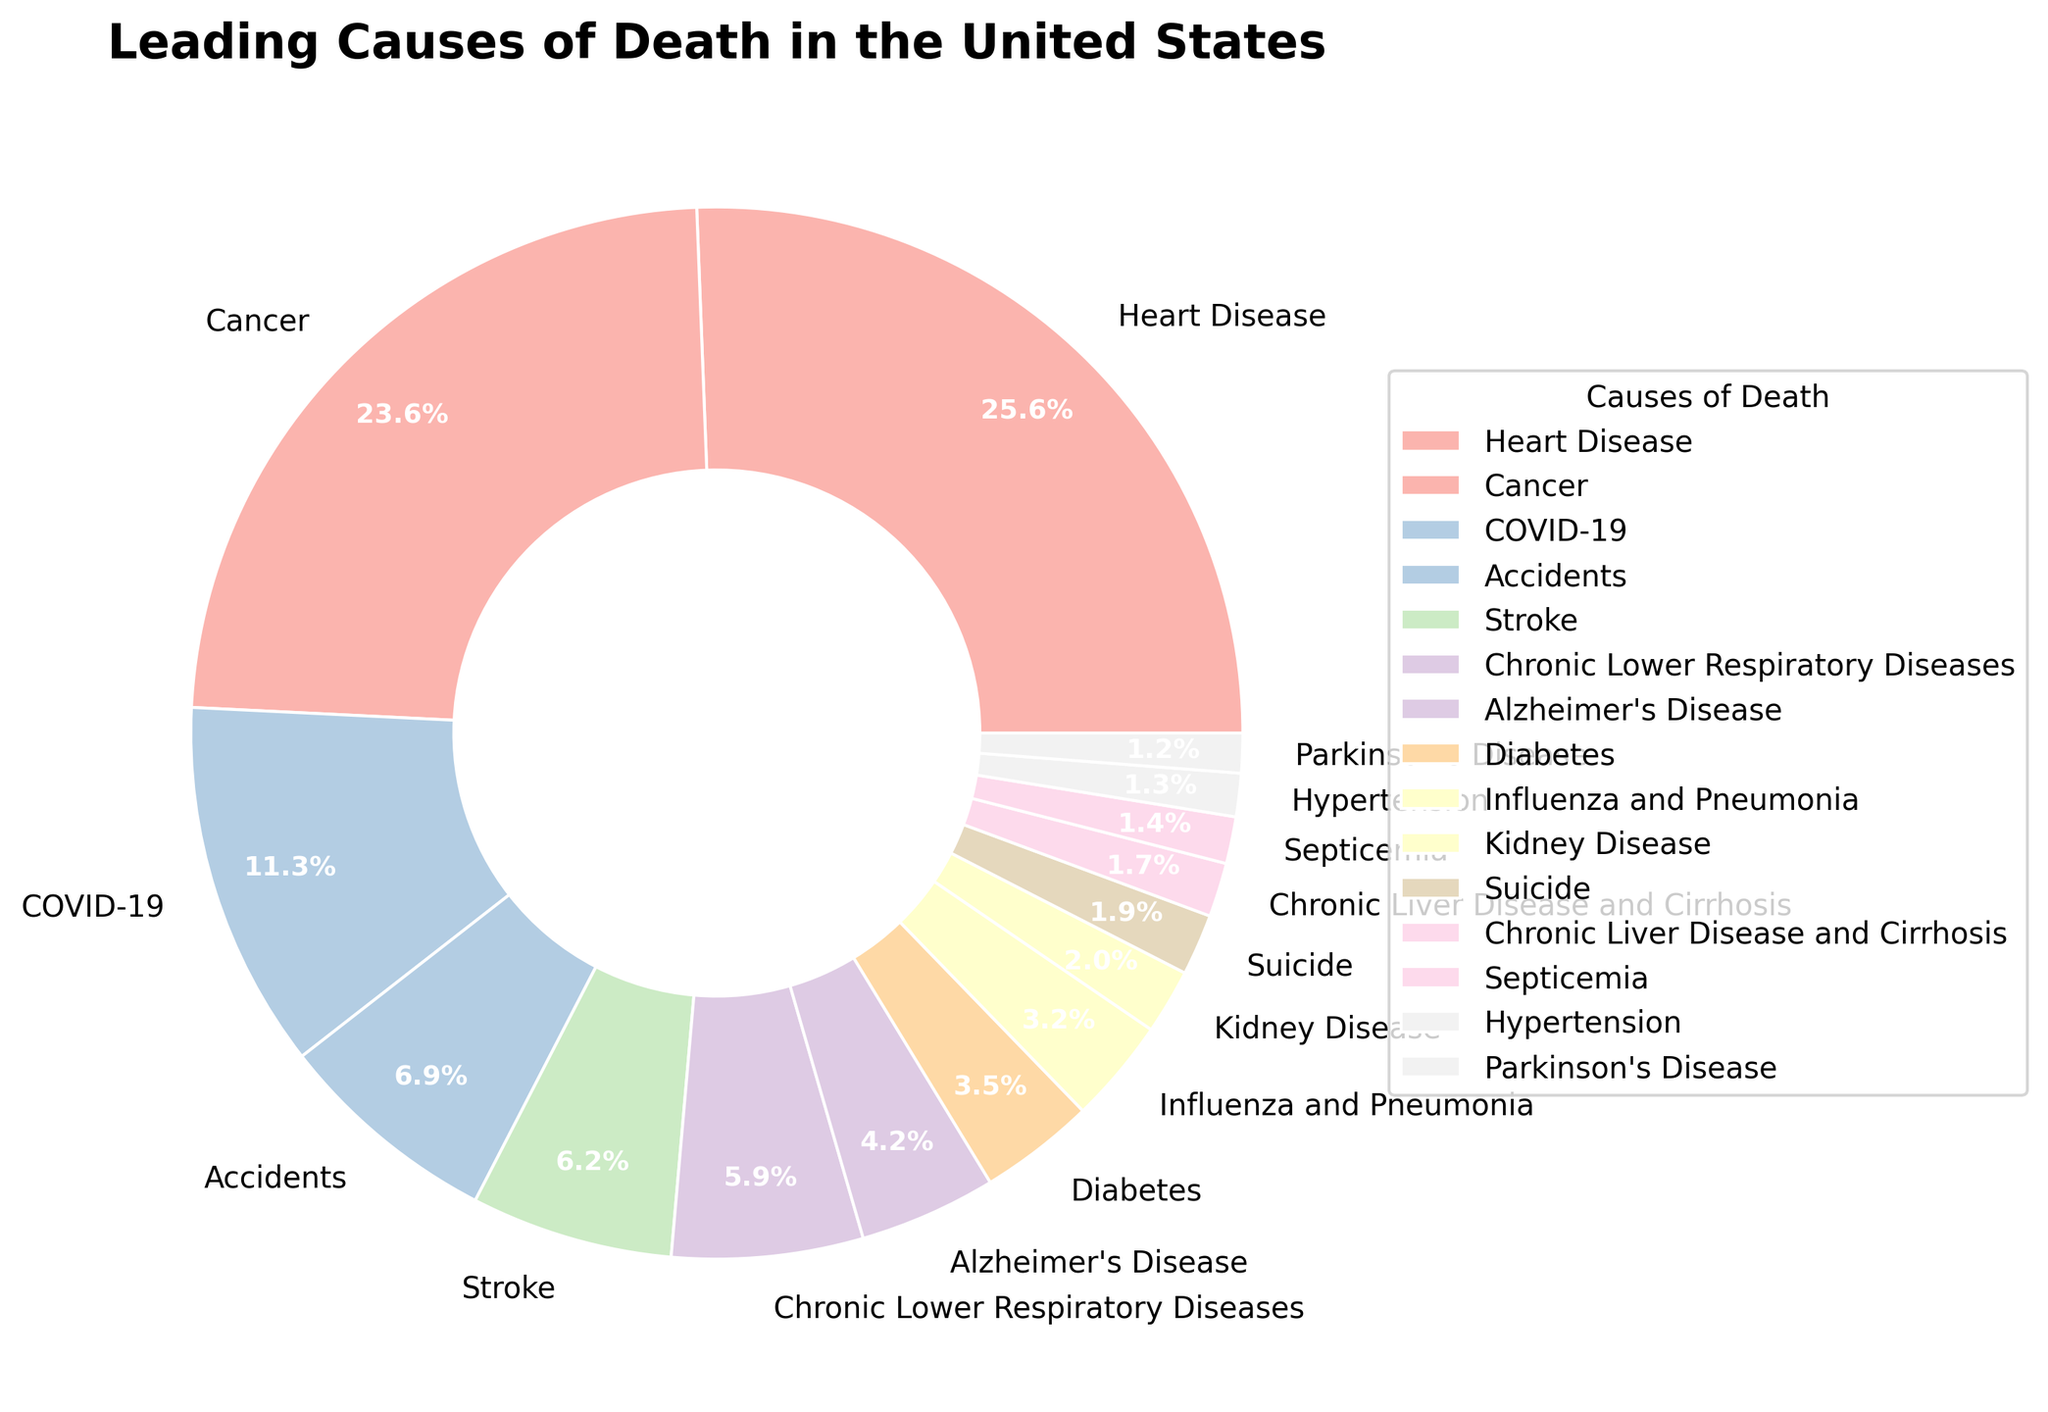Which cause of death has the highest percentage? The pie chart shows the breakdown of each cause of death by percentage. The section representing "Heart Disease" has the largest percentage noted as 23.1%.
Answer: Heart Disease Which causes of death combined make up more than 50% of the total? Summing the highest percentages until the total exceeds 50%, 23.1% (Heart Disease) + 21.3% (Cancer) + 10.2% (COVID-19) results in 54.6%.
Answer: Heart Disease, Cancer, COVID-19 What is the percentage difference between Cancer and Accidents? Cancer accounts for 21.3% and Accidents for 6.2%. Subtracting these gives: 21.3 - 6.2 = 15.1%
Answer: 15.1% Which causes of death have a percentage less than 2%? Scanning through the pie chart, the causes with less than 2% are Kidney Disease (1.8%), Suicide (1.7%), Chronic Liver Disease and Cirrhosis (1.5%), Septicemia (1.3%), Hypertension (1.2%), and Parkinson's Disease (1.1%).
Answer: Kidney Disease, Suicide, Chronic Liver Disease and Cirrhosis, Septicemia, Hypertension, Parkinson's Disease How many categories fall below the 5% threshold? From the chart, Chronic Lower Respiratory Diseases (5.3%) is above 5%, while Stroke (5.6%) is below 5%. Nine (Alzheimer's Disease, Diabetes, Influenza and Pneumonia, Kidney Disease, Suicide, Chronic Liver Disease and Cirrhosis, Septicemia, Hypertension, and Parkinson's Disease) fit this criterion.
Answer: 9 Are there more deaths due to Influenza and Pneumonia or due to Diabetes? Comparing the two percentages, Influenza and Pneumonia account for 2.9%, while Diabetes accounts for 3.2%. Diabetes has a higher percentage.
Answer: Diabetes Which is greater, the total percentage of Alzheimer's Disease and Diabetes or Stroke? Adding percentages for Alzheimer's Disease (3.8%) and Diabetes (3.2%) gives 7.0%, which is greater than Stroke's 5.6%.
Answer: Alzheimer's Disease and Diabetes What is the combined percentage of the three least common causes of death? Adding the three smallest percentages: Parkinson's Disease (1.1%), Hypertension (1.2%), and Septicemia (1.3%), results in 3.6%.
Answer: 3.6% How many causes fall between 3% and 6% in their percentage? Identifying the causes in this range shows Stroke (5.6%), Chronic Lower Respiratory Diseases (5.3%), Alzheimer's Disease (3.8%), and Diabetes (3.2%) for a total of four.
Answer: 4 